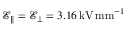Convert formula to latex. <formula><loc_0><loc_0><loc_500><loc_500>\mathcal { E } _ { \| } = \mathcal { E } _ { \bot } = 3 . 1 6 \, k V \, m m ^ { - 1 }</formula> 